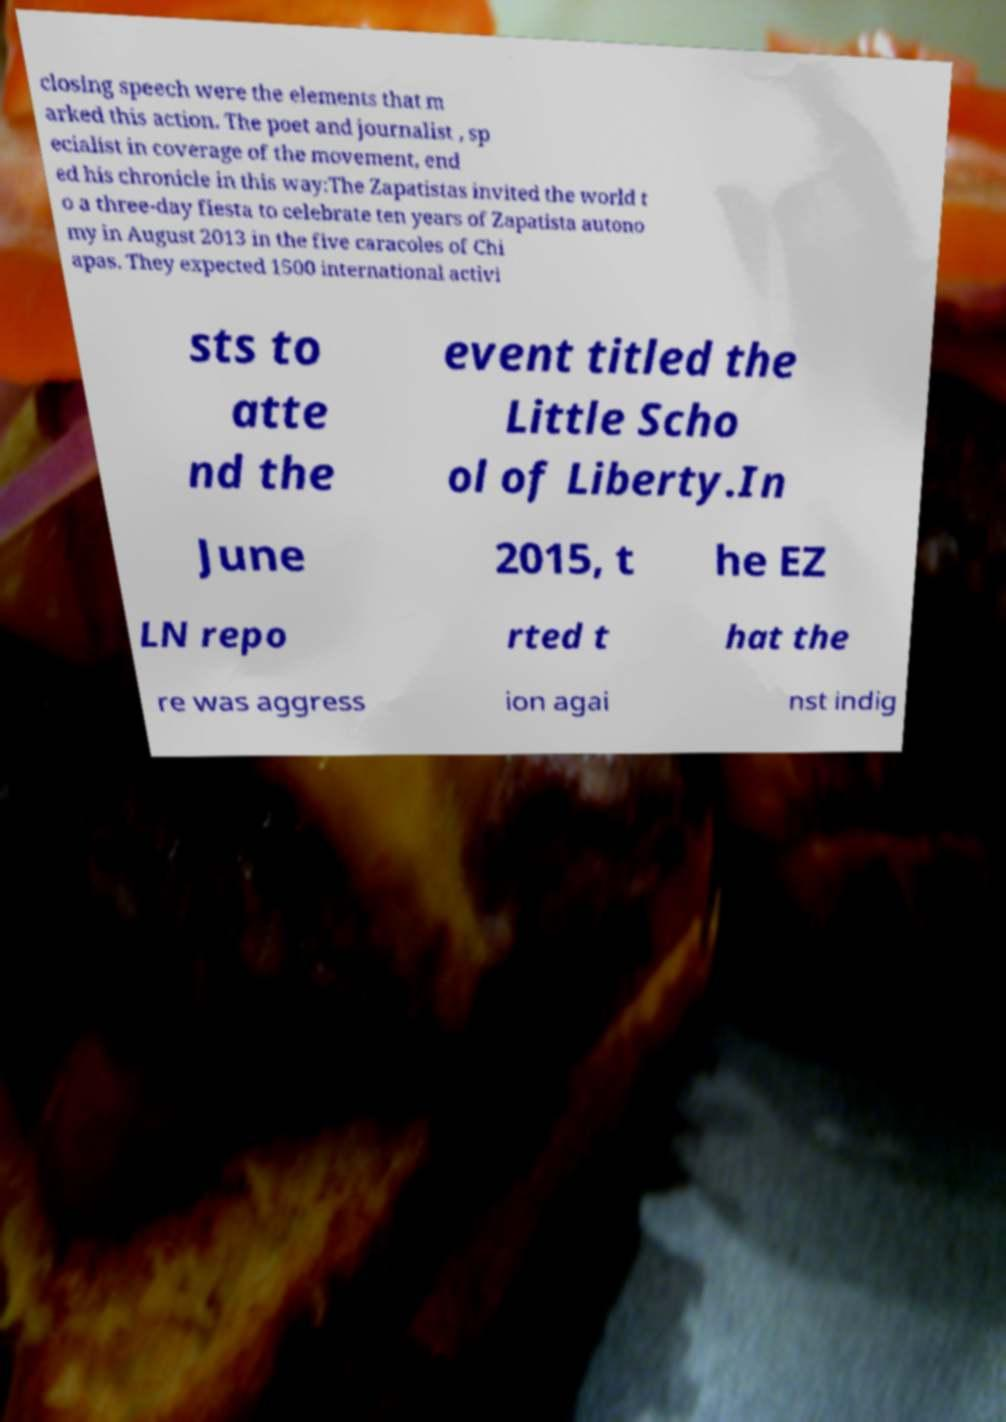I need the written content from this picture converted into text. Can you do that? closing speech were the elements that m arked this action. The poet and journalist , sp ecialist in coverage of the movement, end ed his chronicle in this way:The Zapatistas invited the world t o a three-day fiesta to celebrate ten years of Zapatista autono my in August 2013 in the five caracoles of Chi apas. They expected 1500 international activi sts to atte nd the event titled the Little Scho ol of Liberty.In June 2015, t he EZ LN repo rted t hat the re was aggress ion agai nst indig 